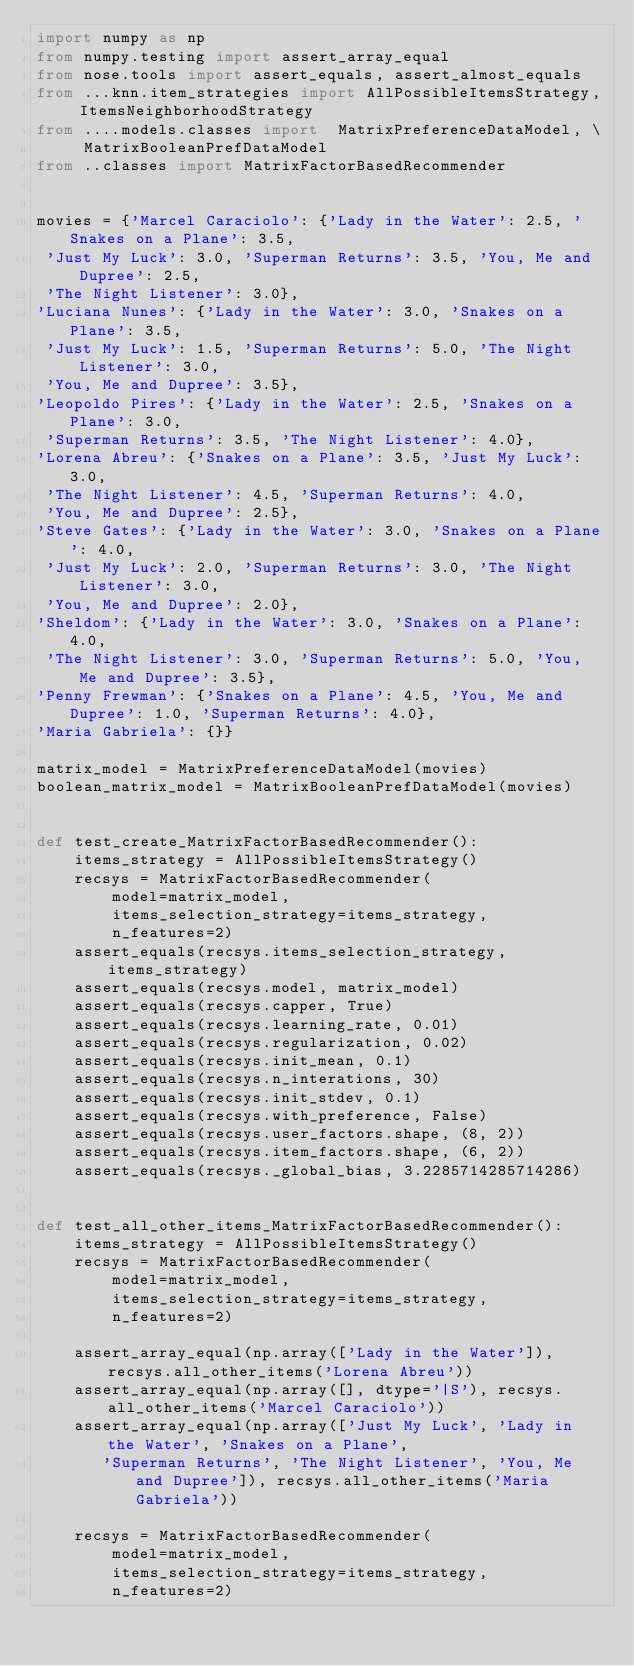<code> <loc_0><loc_0><loc_500><loc_500><_Python_>import numpy as np
from numpy.testing import assert_array_equal
from nose.tools import assert_equals, assert_almost_equals
from ...knn.item_strategies import AllPossibleItemsStrategy, ItemsNeighborhoodStrategy
from ....models.classes import  MatrixPreferenceDataModel, \
     MatrixBooleanPrefDataModel
from ..classes import MatrixFactorBasedRecommender


movies = {'Marcel Caraciolo': {'Lady in the Water': 2.5, 'Snakes on a Plane': 3.5,
 'Just My Luck': 3.0, 'Superman Returns': 3.5, 'You, Me and Dupree': 2.5,
 'The Night Listener': 3.0},
'Luciana Nunes': {'Lady in the Water': 3.0, 'Snakes on a Plane': 3.5,
 'Just My Luck': 1.5, 'Superman Returns': 5.0, 'The Night Listener': 3.0,
 'You, Me and Dupree': 3.5},
'Leopoldo Pires': {'Lady in the Water': 2.5, 'Snakes on a Plane': 3.0,
 'Superman Returns': 3.5, 'The Night Listener': 4.0},
'Lorena Abreu': {'Snakes on a Plane': 3.5, 'Just My Luck': 3.0,
 'The Night Listener': 4.5, 'Superman Returns': 4.0,
 'You, Me and Dupree': 2.5},
'Steve Gates': {'Lady in the Water': 3.0, 'Snakes on a Plane': 4.0,
 'Just My Luck': 2.0, 'Superman Returns': 3.0, 'The Night Listener': 3.0,
 'You, Me and Dupree': 2.0},
'Sheldom': {'Lady in the Water': 3.0, 'Snakes on a Plane': 4.0,
 'The Night Listener': 3.0, 'Superman Returns': 5.0, 'You, Me and Dupree': 3.5},
'Penny Frewman': {'Snakes on a Plane': 4.5, 'You, Me and Dupree': 1.0, 'Superman Returns': 4.0},
'Maria Gabriela': {}}

matrix_model = MatrixPreferenceDataModel(movies)
boolean_matrix_model = MatrixBooleanPrefDataModel(movies)


def test_create_MatrixFactorBasedRecommender():
    items_strategy = AllPossibleItemsStrategy()
    recsys = MatrixFactorBasedRecommender(
        model=matrix_model,
        items_selection_strategy=items_strategy,
        n_features=2)
    assert_equals(recsys.items_selection_strategy, items_strategy)
    assert_equals(recsys.model, matrix_model)
    assert_equals(recsys.capper, True)
    assert_equals(recsys.learning_rate, 0.01)
    assert_equals(recsys.regularization, 0.02)
    assert_equals(recsys.init_mean, 0.1)
    assert_equals(recsys.n_interations, 30)
    assert_equals(recsys.init_stdev, 0.1)
    assert_equals(recsys.with_preference, False)
    assert_equals(recsys.user_factors.shape, (8, 2))
    assert_equals(recsys.item_factors.shape, (6, 2))
    assert_equals(recsys._global_bias, 3.2285714285714286)


def test_all_other_items_MatrixFactorBasedRecommender():
    items_strategy = AllPossibleItemsStrategy()
    recsys = MatrixFactorBasedRecommender(
        model=matrix_model,
        items_selection_strategy=items_strategy,
        n_features=2)

    assert_array_equal(np.array(['Lady in the Water']), recsys.all_other_items('Lorena Abreu'))
    assert_array_equal(np.array([], dtype='|S'), recsys.all_other_items('Marcel Caraciolo'))
    assert_array_equal(np.array(['Just My Luck', 'Lady in the Water', 'Snakes on a Plane',
       'Superman Returns', 'The Night Listener', 'You, Me and Dupree']), recsys.all_other_items('Maria Gabriela'))

    recsys = MatrixFactorBasedRecommender(
        model=matrix_model,
        items_selection_strategy=items_strategy,
        n_features=2)
</code> 